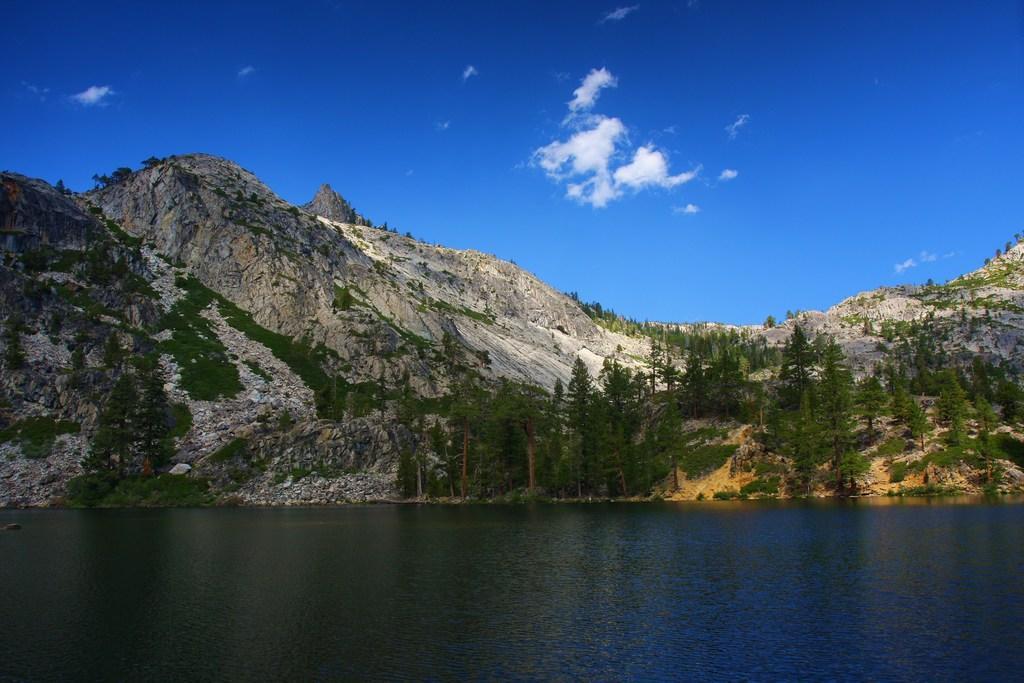Describe this image in one or two sentences. In this picture there is water and there are few trees and mountains in the background and the sky is in blue color. 